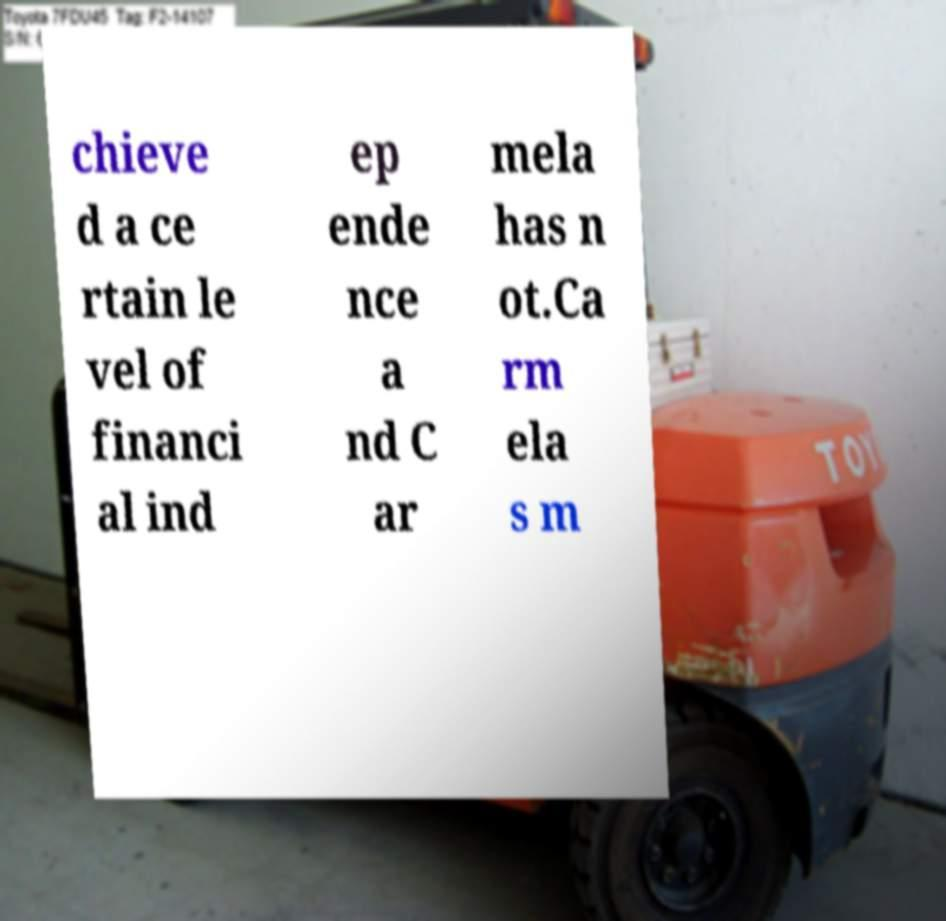Could you assist in decoding the text presented in this image and type it out clearly? chieve d a ce rtain le vel of financi al ind ep ende nce a nd C ar mela has n ot.Ca rm ela s m 